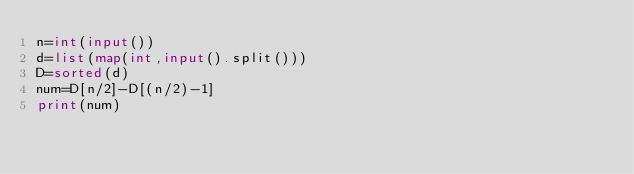<code> <loc_0><loc_0><loc_500><loc_500><_Python_>n=int(input())
d=list(map(int,input().split()))
D=sorted(d)
num=D[n/2]-D[(n/2)-1]
print(num)</code> 